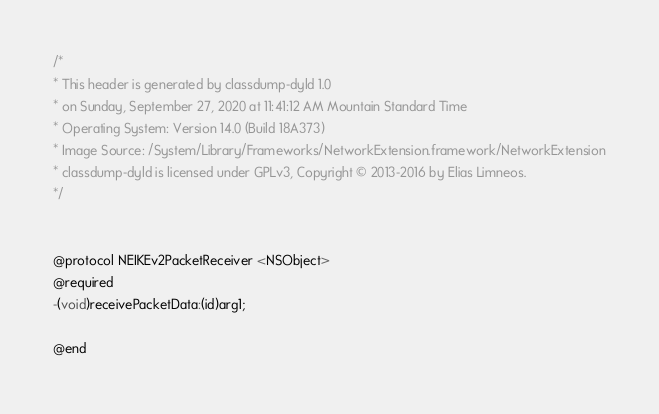Convert code to text. <code><loc_0><loc_0><loc_500><loc_500><_C_>/*
* This header is generated by classdump-dyld 1.0
* on Sunday, September 27, 2020 at 11:41:12 AM Mountain Standard Time
* Operating System: Version 14.0 (Build 18A373)
* Image Source: /System/Library/Frameworks/NetworkExtension.framework/NetworkExtension
* classdump-dyld is licensed under GPLv3, Copyright © 2013-2016 by Elias Limneos.
*/


@protocol NEIKEv2PacketReceiver <NSObject>
@required
-(void)receivePacketData:(id)arg1;

@end

</code> 